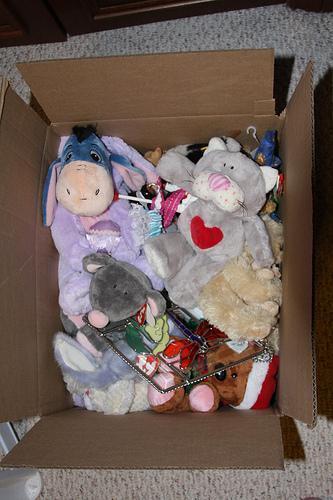How many stuffed animals have a heart on their chest?
Give a very brief answer. 1. 